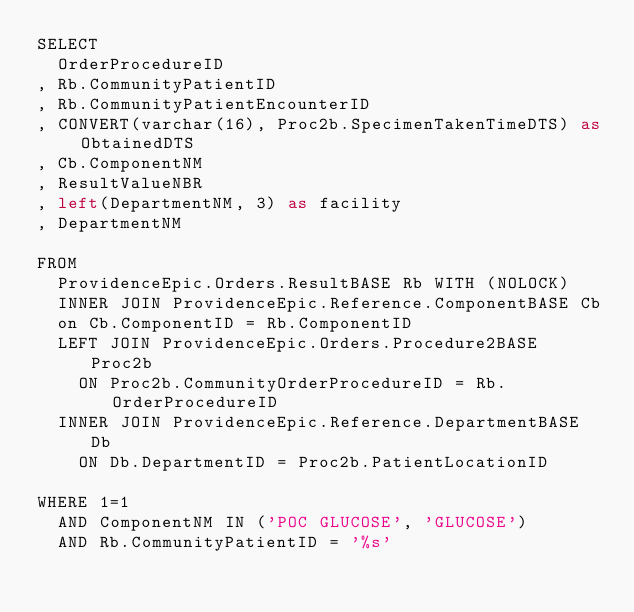Convert code to text. <code><loc_0><loc_0><loc_500><loc_500><_SQL_>SELECT
  OrderProcedureID
, Rb.CommunityPatientID
, Rb.CommunityPatientEncounterID
, CONVERT(varchar(16), Proc2b.SpecimenTakenTimeDTS) as ObtainedDTS
, Cb.ComponentNM
, ResultValueNBR
, left(DepartmentNM, 3) as facility
, DepartmentNM

FROM
  ProvidenceEpic.Orders.ResultBASE Rb WITH (NOLOCK)
  INNER JOIN ProvidenceEpic.Reference.ComponentBASE Cb
  on Cb.ComponentID = Rb.ComponentID
  LEFT JOIN ProvidenceEpic.Orders.Procedure2BASE Proc2b
    ON Proc2b.CommunityOrderProcedureID = Rb.OrderProcedureID
  INNER JOIN ProvidenceEpic.Reference.DepartmentBASE Db
    ON Db.DepartmentID = Proc2b.PatientLocationID

WHERE 1=1
  AND ComponentNM IN ('POC GLUCOSE', 'GLUCOSE')
  AND Rb.CommunityPatientID = '%s'
</code> 